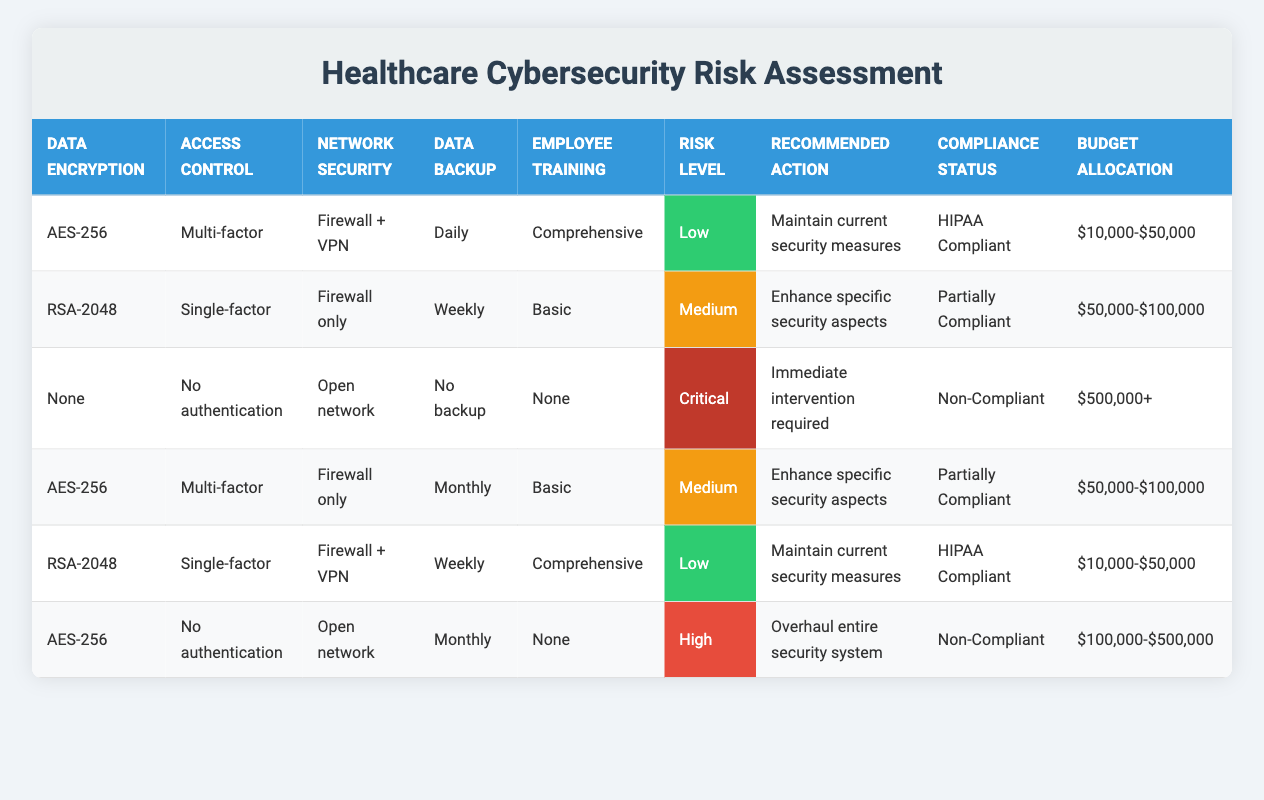What is the risk level for a data system with AES-256 encryption, multi-factor access control, firewall + VPN, daily backup, and comprehensive employee training? According to the table, this combination corresponds to the first row, which indicates a risk level of "Low."
Answer: Low Is the compliance status for a system using RSA-2048, single-factor access control, and weekly backups considered HIPAA Compliant? The table indicates that this combination is found in the second row, where the compliance status is listed as "Partially Compliant," so it is not HIPAA Compliant.
Answer: No What is the recommended action for a system with no data backup, open network, and no employee training? This situation corresponds to the third row, which states that the recommended action is "Immediate intervention required."
Answer: Immediate intervention required How many systems are classified as having a high risk level? In the table, we look for the "High" risk level, which appears only once in the last row, indicating there is only one system with a high risk level.
Answer: 1 What is the average budget allocation for systems with a risk level of "Medium"? There are two systems with a "Medium" risk level: one is allocated $50,000-$100,000 (second row) and the other is also allocated $50,000-$100,000 (fourth row). The average allocation is therefore calculated as ($50,000-$100,000 + $50,000-$100,000) / 2 = $50,000-$100,000.
Answer: $50,000-$100,000 Are there any systems that have both AES-256 encryption and a non-compliant status? By scanning the table, AES-256 encryption appears in two instances, but both correlate with compliant statuses (one being HIPAA Compliant and the other being Partially Compliant), so no systems with AES-256 encryption are non-compliant.
Answer: No What is the highest risk level associated with the lowest level of employee training? The third row has the lowest level of employee training ("None") and indicates a risk level of "Critical," making it the highest risk level under the criteria of no training.
Answer: Critical What is the number of systems that have backup frequency set to daily? From the table, there is only one system that has daily backup (the first row), confirming that only a single system meets this criterion.
Answer: 1 Which access control option has the majority of systems categorized as low risk? Analyzing the rows, "Multi-factor" access control is associated with two low-risk systems (first and fifth row), making it the most common access control option for low risk.
Answer: Multi-factor 